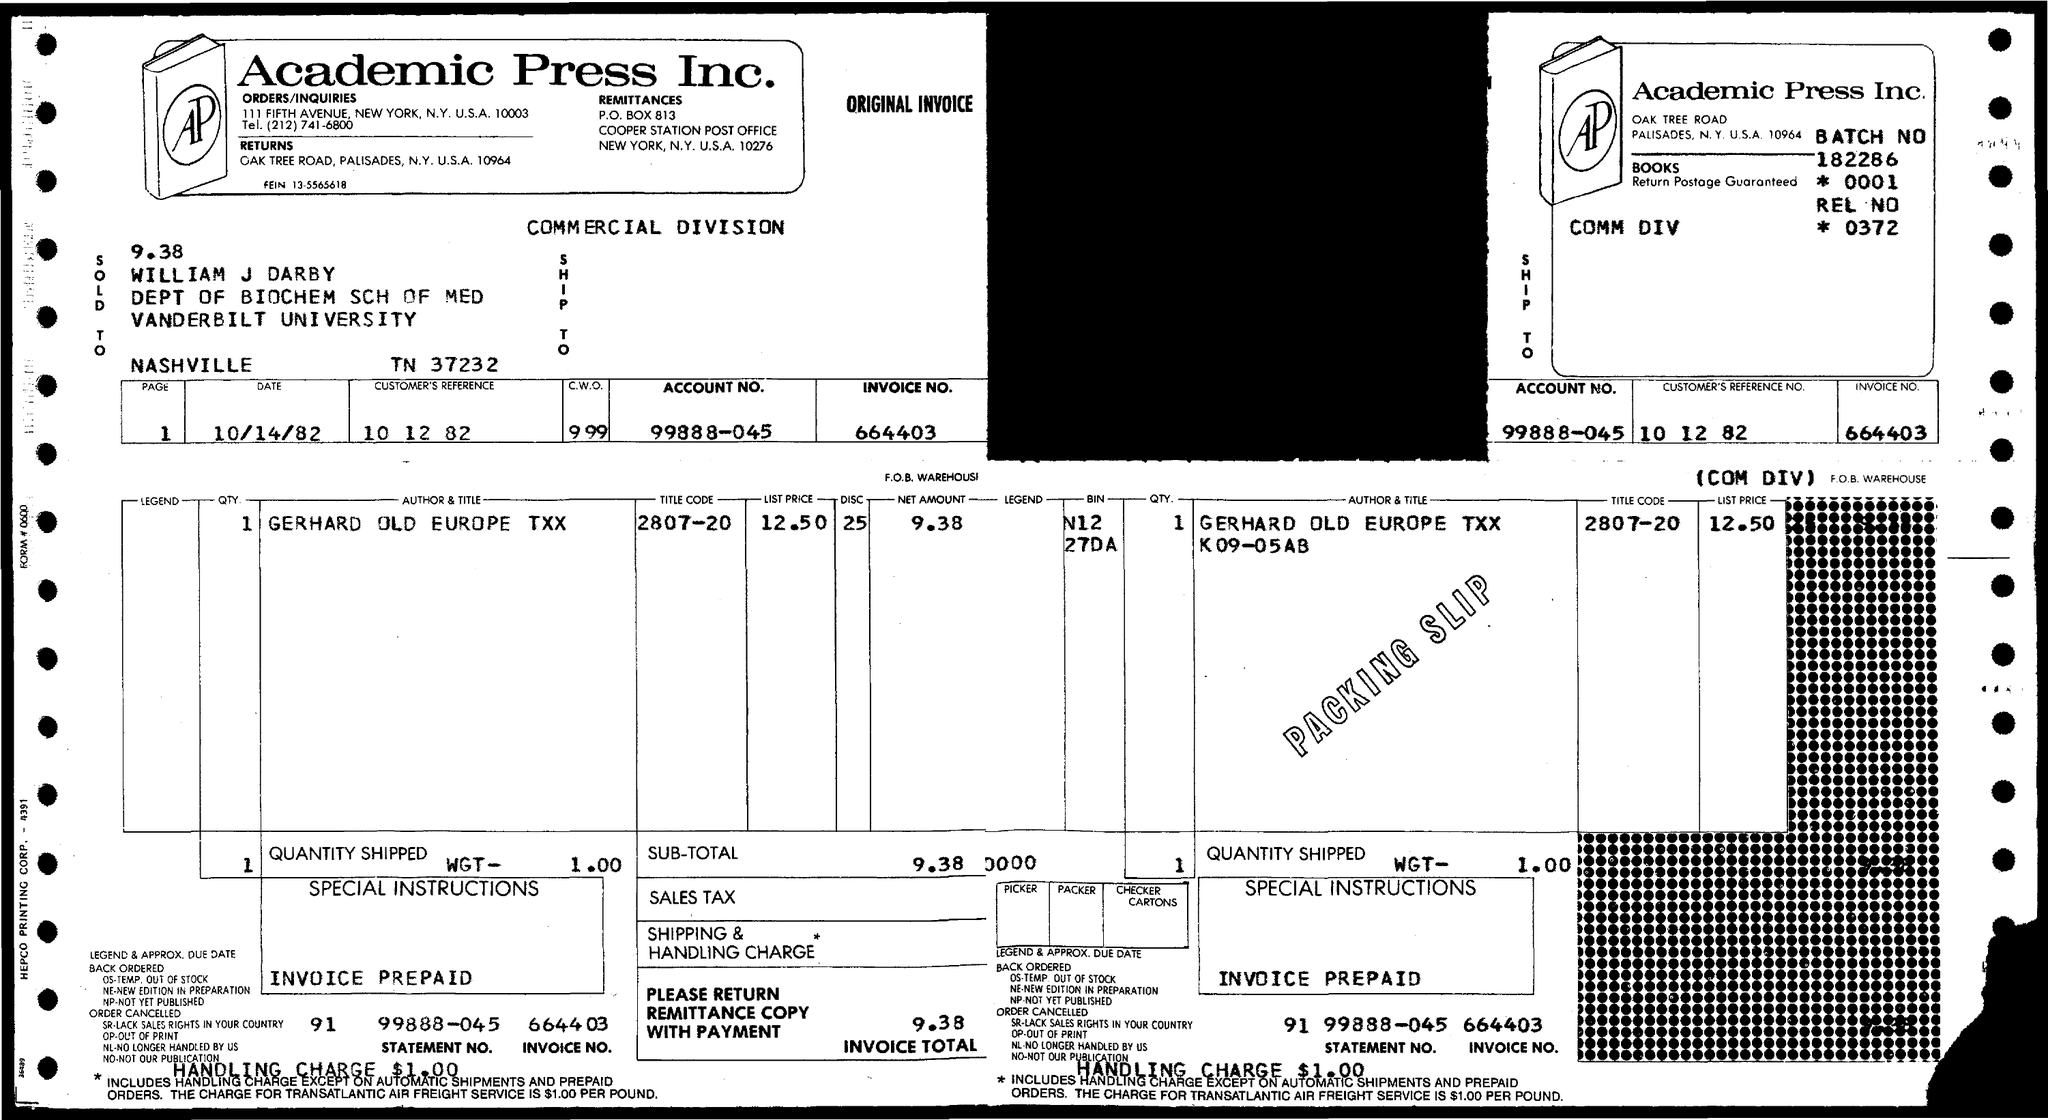Give some essential details in this illustration. Please provide the invoice number, which is 664403... The account number is 99888-045... The company name is Academic Press Inc. The invoice total is 9.38. 